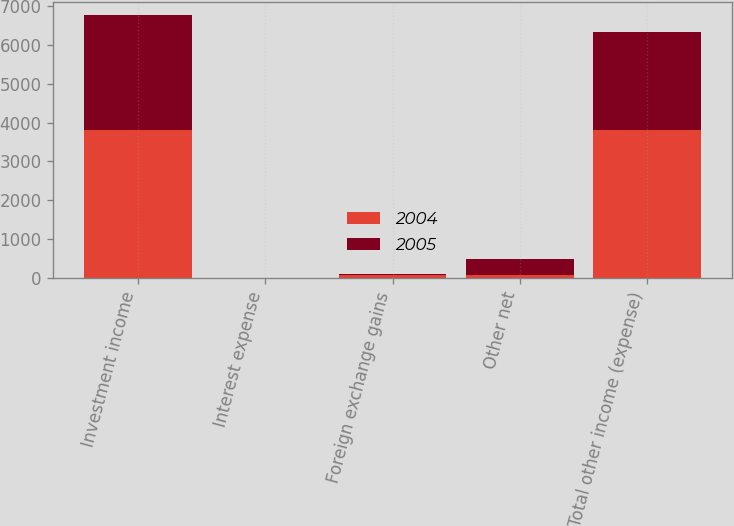Convert chart. <chart><loc_0><loc_0><loc_500><loc_500><stacked_bar_chart><ecel><fcel>Investment income<fcel>Interest expense<fcel>Foreign exchange gains<fcel>Other net<fcel>Total other income (expense)<nl><fcel>2004<fcel>3814<fcel>8<fcel>87<fcel>74<fcel>3819<nl><fcel>2005<fcel>2949<fcel>5<fcel>9<fcel>419<fcel>2516<nl></chart> 